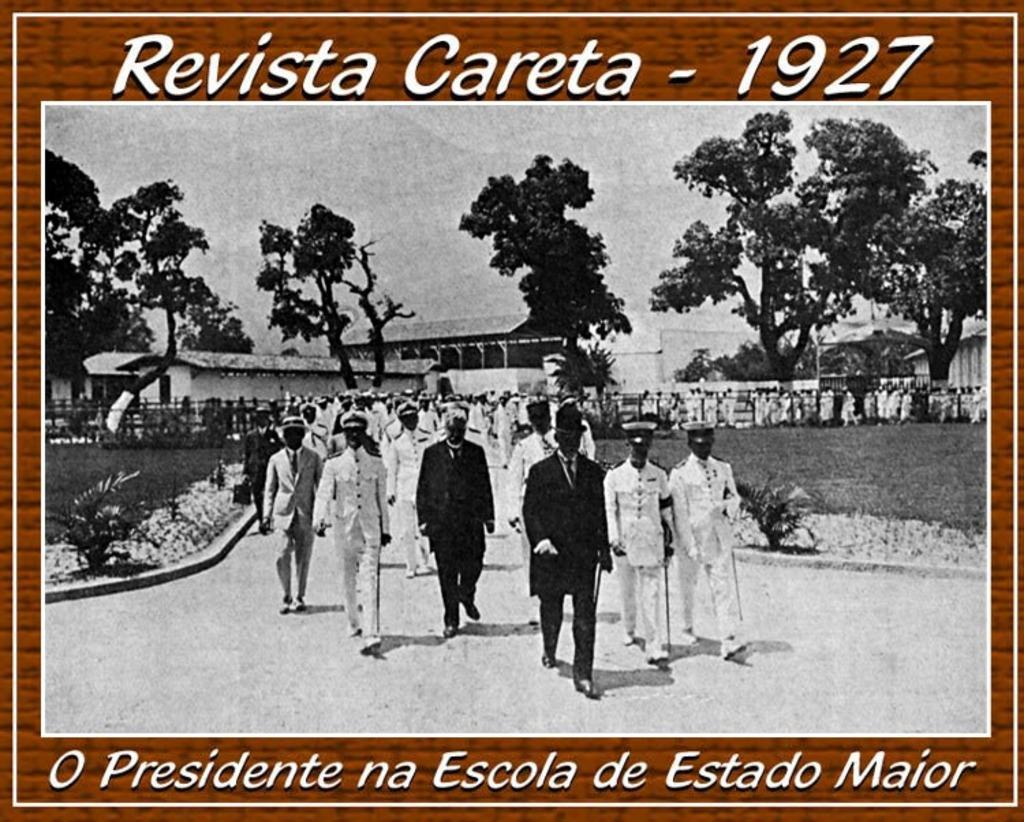<image>
Present a compact description of the photo's key features. The image says Revista Careta - 1927 above a photo of a large procession of military personnel. 